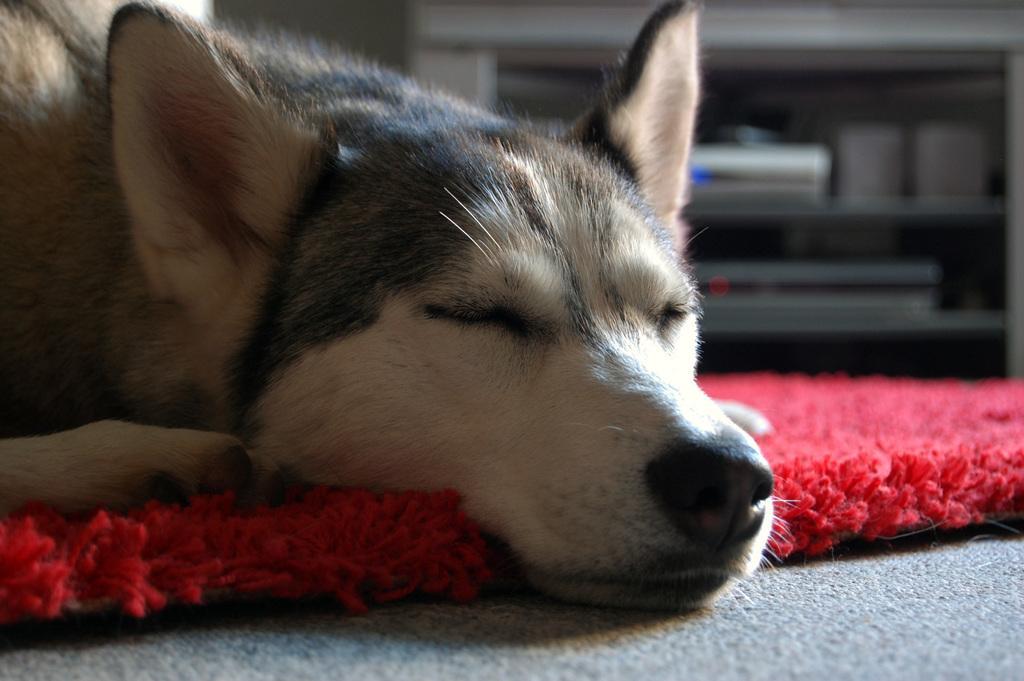Please provide a concise description of this image. In this image, I can see a dog sleeping. This looks like a floor mat, which is red in color. In the background, I think these are the electronic devices, which are in the rack. 